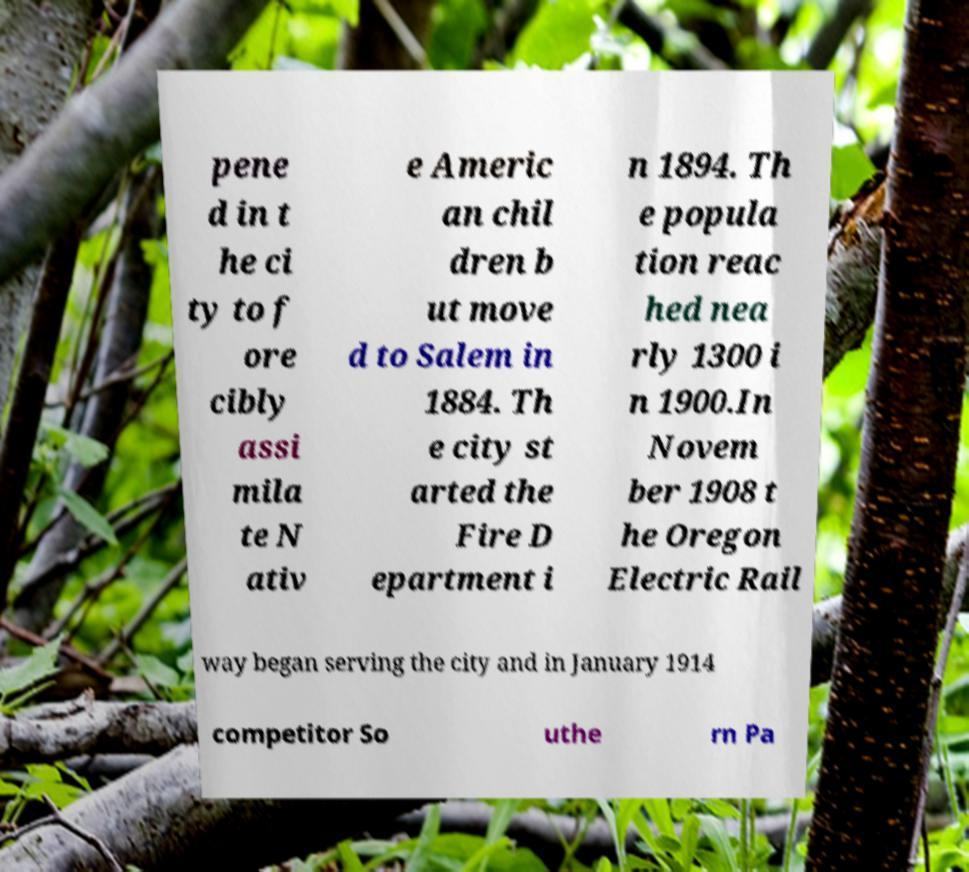Can you accurately transcribe the text from the provided image for me? pene d in t he ci ty to f ore cibly assi mila te N ativ e Americ an chil dren b ut move d to Salem in 1884. Th e city st arted the Fire D epartment i n 1894. Th e popula tion reac hed nea rly 1300 i n 1900.In Novem ber 1908 t he Oregon Electric Rail way began serving the city and in January 1914 competitor So uthe rn Pa 